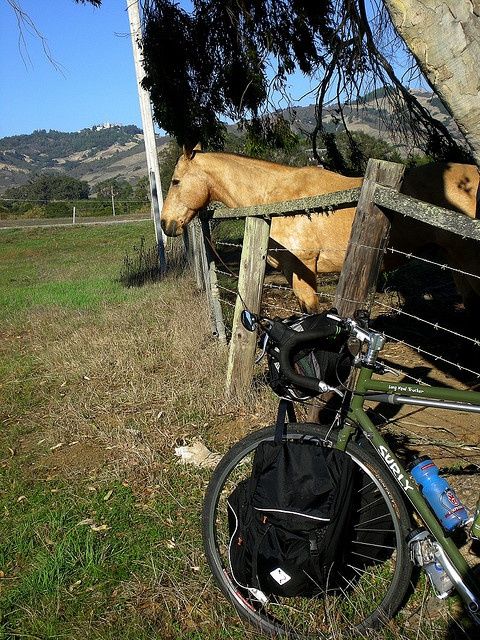Describe the objects in this image and their specific colors. I can see bicycle in lightblue, black, gray, darkgreen, and darkgray tones, horse in lightblue, black, and tan tones, backpack in lightblue, black, gray, white, and darkgray tones, bottle in lightblue, gray, and black tones, and bottle in lightblue, darkgray, gray, and black tones in this image. 